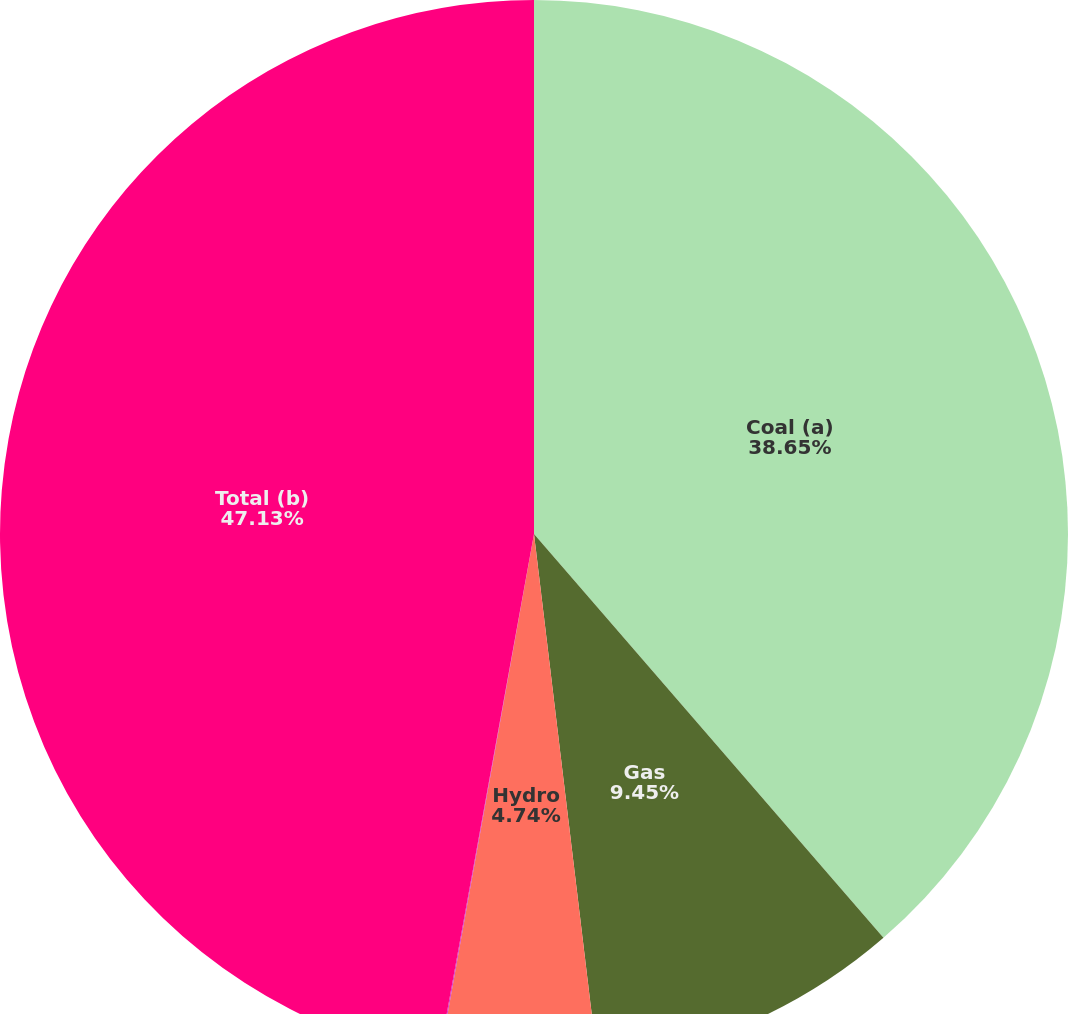Convert chart to OTSL. <chart><loc_0><loc_0><loc_500><loc_500><pie_chart><fcel>Coal (a)<fcel>Gas<fcel>Hydro<fcel>Solar<fcel>Total (b)<nl><fcel>38.65%<fcel>9.45%<fcel>4.74%<fcel>0.03%<fcel>47.14%<nl></chart> 